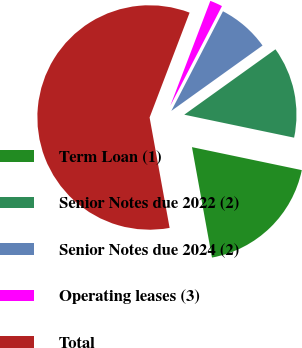Convert chart to OTSL. <chart><loc_0><loc_0><loc_500><loc_500><pie_chart><fcel>Term Loan (1)<fcel>Senior Notes due 2022 (2)<fcel>Senior Notes due 2024 (2)<fcel>Operating leases (3)<fcel>Total<nl><fcel>18.86%<fcel>13.18%<fcel>7.49%<fcel>1.81%<fcel>58.65%<nl></chart> 